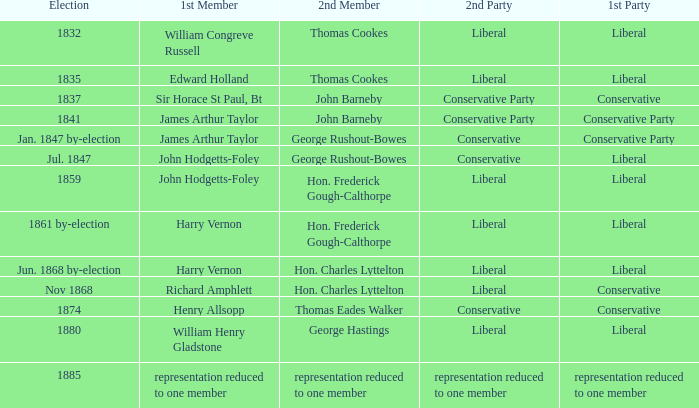If the first party was liberal and george rushout-bowes was the second member, what was the name of the second party? Conservative. 